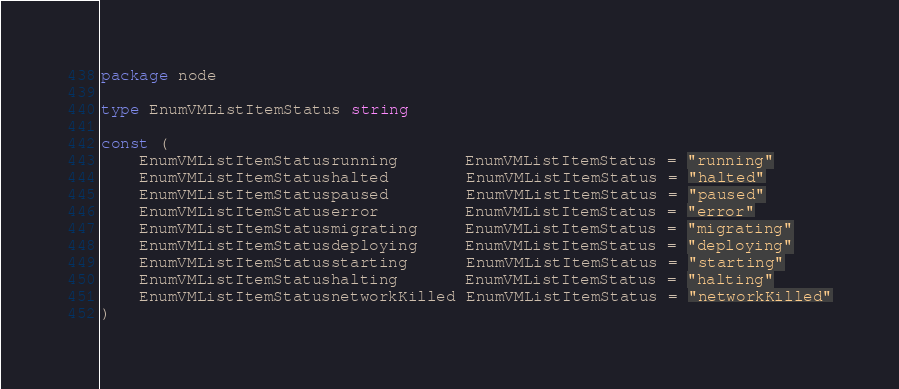Convert code to text. <code><loc_0><loc_0><loc_500><loc_500><_Go_>package node

type EnumVMListItemStatus string

const (
	EnumVMListItemStatusrunning       EnumVMListItemStatus = "running"
	EnumVMListItemStatushalted        EnumVMListItemStatus = "halted"
	EnumVMListItemStatuspaused        EnumVMListItemStatus = "paused"
	EnumVMListItemStatuserror         EnumVMListItemStatus = "error"
	EnumVMListItemStatusmigrating     EnumVMListItemStatus = "migrating"
	EnumVMListItemStatusdeploying     EnumVMListItemStatus = "deploying"
	EnumVMListItemStatusstarting      EnumVMListItemStatus = "starting"
	EnumVMListItemStatushalting       EnumVMListItemStatus = "halting"
	EnumVMListItemStatusnetworkKilled EnumVMListItemStatus = "networkKilled"
)
</code> 